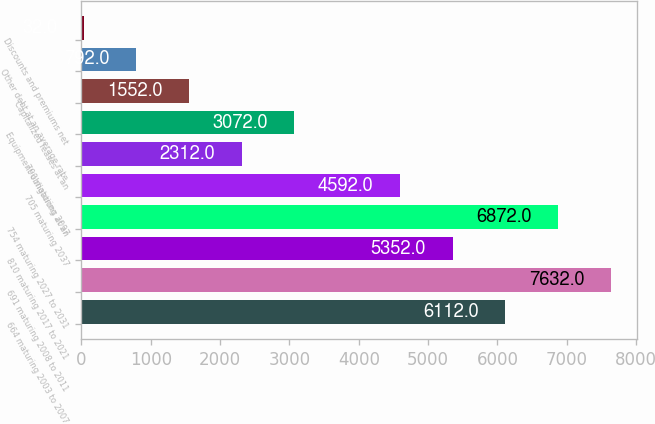Convert chart. <chart><loc_0><loc_0><loc_500><loc_500><bar_chart><fcel>664 maturing 2003 to 2007<fcel>691 maturing 2008 to 2011<fcel>810 maturing 2017 to 2021<fcel>754 maturing 2027 to 2031<fcel>705 maturing 2037<fcel>790 maturing 2097<fcel>Equipment obligations at an<fcel>Capitalized leases at an<fcel>Other debt at an average rate<fcel>Discounts and premiums net<nl><fcel>6112<fcel>7632<fcel>5352<fcel>6872<fcel>4592<fcel>2312<fcel>3072<fcel>1552<fcel>792<fcel>32<nl></chart> 